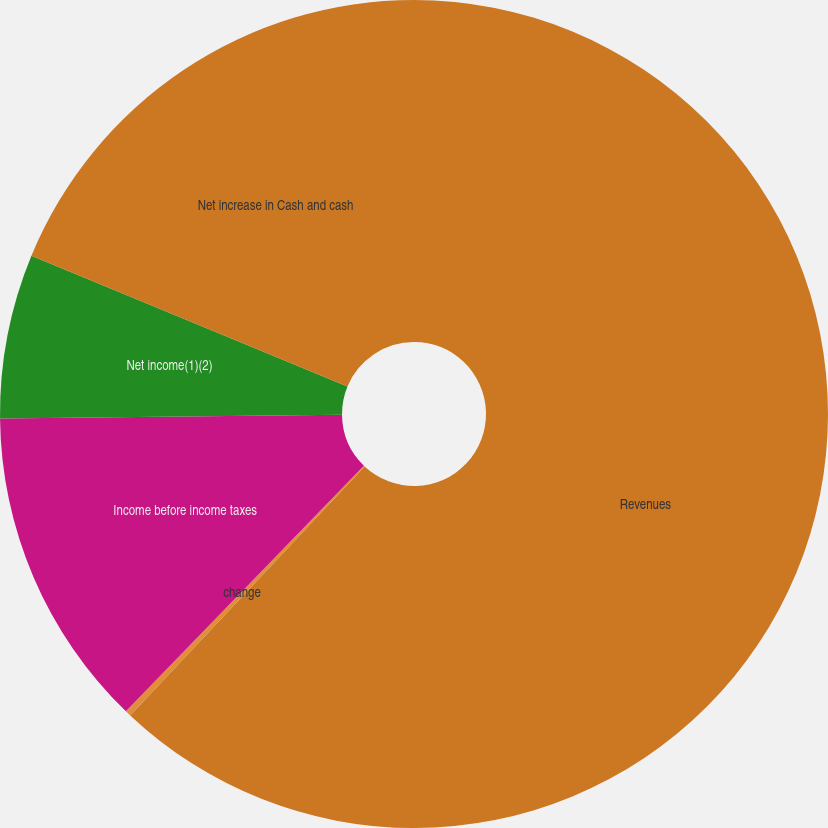Convert chart. <chart><loc_0><loc_0><loc_500><loc_500><pie_chart><fcel>Revenues<fcel>change<fcel>Income before income taxes<fcel>Net income(1)(2)<fcel>Net increase in Cash and cash<nl><fcel>62.02%<fcel>0.23%<fcel>12.58%<fcel>6.41%<fcel>18.76%<nl></chart> 